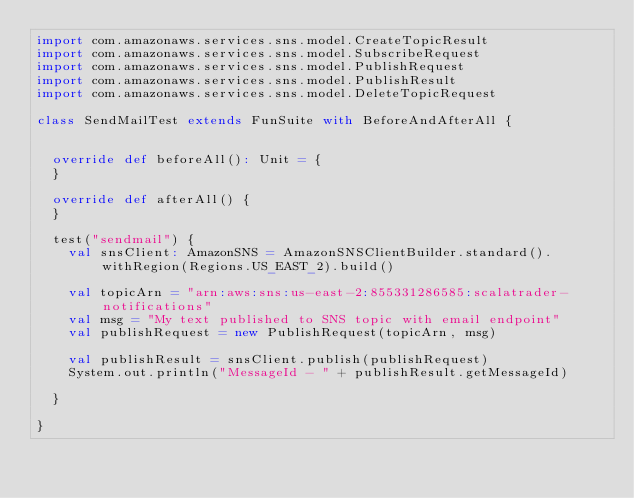<code> <loc_0><loc_0><loc_500><loc_500><_Scala_>import com.amazonaws.services.sns.model.CreateTopicResult
import com.amazonaws.services.sns.model.SubscribeRequest
import com.amazonaws.services.sns.model.PublishRequest
import com.amazonaws.services.sns.model.PublishResult
import com.amazonaws.services.sns.model.DeleteTopicRequest

class SendMailTest extends FunSuite with BeforeAndAfterAll {


  override def beforeAll(): Unit = {
  }

  override def afterAll() {
  }

  test("sendmail") {
    val snsClient: AmazonSNS = AmazonSNSClientBuilder.standard().withRegion(Regions.US_EAST_2).build()

    val topicArn = "arn:aws:sns:us-east-2:855331286585:scalatrader-notifications"
    val msg = "My text published to SNS topic with email endpoint"
    val publishRequest = new PublishRequest(topicArn, msg)

    val publishResult = snsClient.publish(publishRequest)
    System.out.println("MessageId - " + publishResult.getMessageId)

  }

}
</code> 